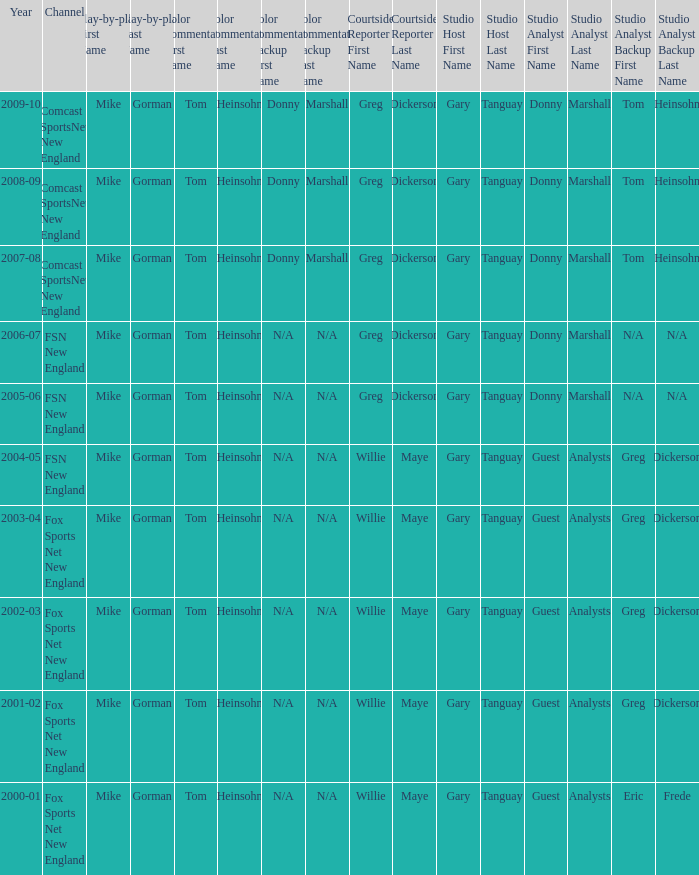Which Courtside reporter has a Channel of fsn new england in 2006-07? Greg Dickerson. 